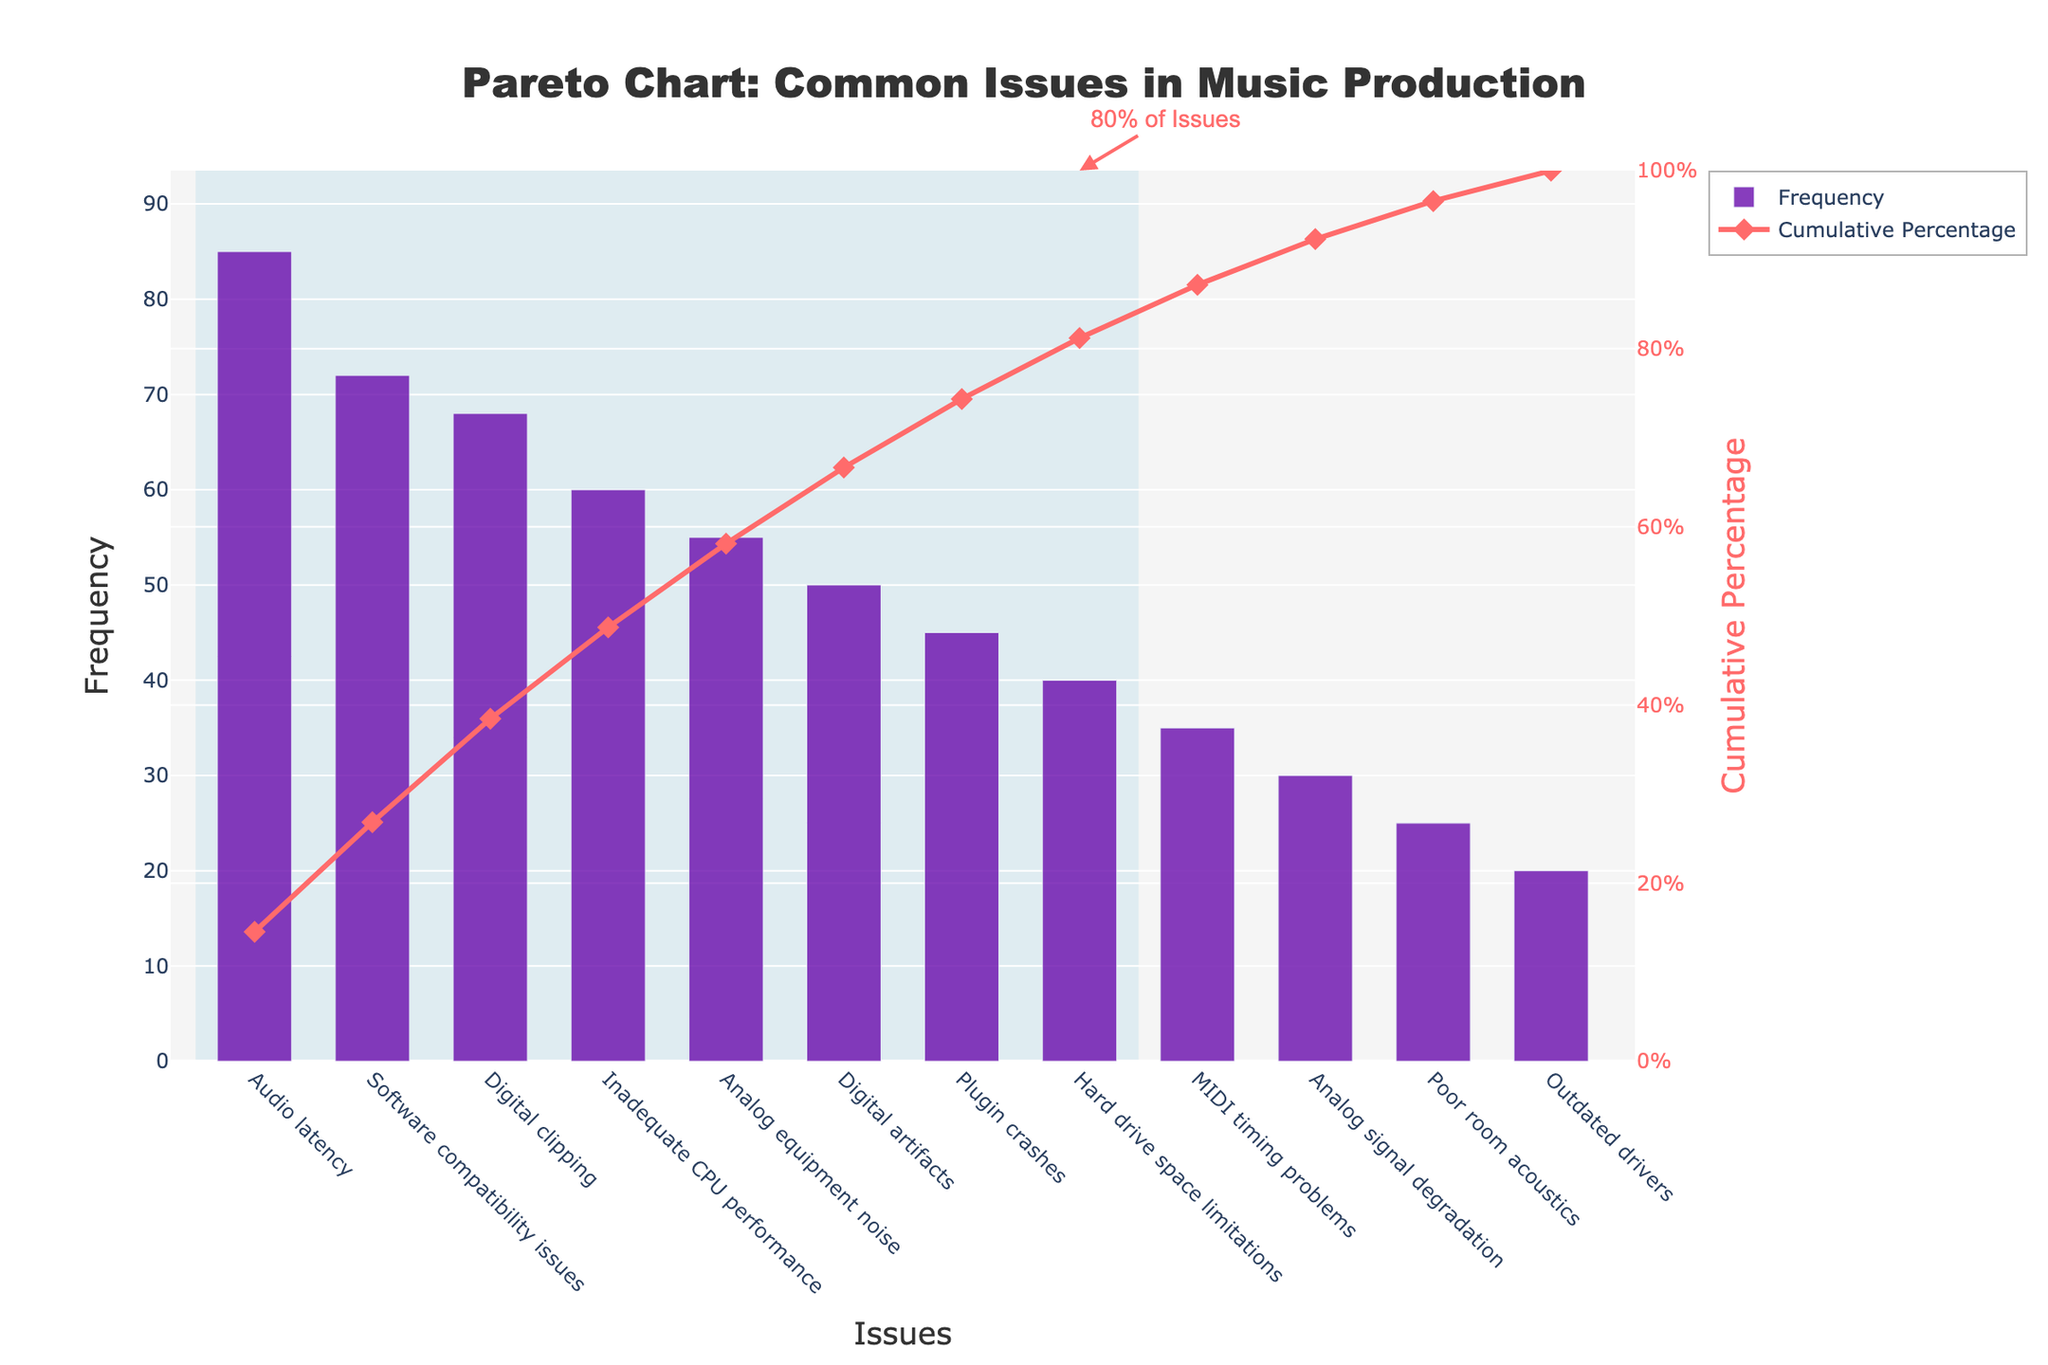What is the title of the chart? The title of the chart can be found at the top center of the figure. It reads "Pareto Chart: Common Issues in Music Production."
Answer: Pareto Chart: Common Issues in Music Production How many issues are identified in the chart? Count the number of unique bars in the chart representing different issues. Each bar corresponds to one issue. There are 12 bars in total.
Answer: 12 Which issue has the highest frequency? Look for the tallest bar on the left side of the chart. This represents "Audio latency."
Answer: Audio latency What is the cumulative percentage for "Software compatibility issues"? Locate the point corresponding to "Software compatibility issues" on the red line representing cumulative percentage. The y-axis on the right shows the percentage. It is approximately around 42%.
Answer: ~42% What percentage of issues account for 80% of the frequency? The chart uses a rectangle to highlight the most significant issues up to 80% of the cumulative percentage. The number of highlighted bars can be counted. There are 7 issues under this highlighted region.
Answer: 7 issues How does the frequency of "Digital clipping" compare to "Analog equipment noise"? Find the bars corresponding to "Digital clipping" and "Analog equipment noise." "Digital clipping" is slightly taller than "Analog equipment noise," which means it has a higher frequency.
Answer: Digital clipping has a higher frequency What is the cumulative percentage after considering "Inadequate CPU performance"? Locate the point representing "Inadequate CPU performance" on the cumulative percentage line. The corresponding percentage on the y-axis (right) is around 72%.
Answer: ~72% Which issue has a higher impact on workflow: "Audio latency" or "Poor room acoustics"? Refer to the data listing both frequency and impact values. Audio latency has an impact of 9.5, while Poor room acoustics has an impact of 8.8. Therefore, Audio latency has a higher impact.
Answer: Audio latency What is the total frequency of the top 3 issues? The top 3 issues are "Audio latency," "Software compatibility issues," and "Digital clipping." Adding their frequencies: 85 (Audio latency) + 72 (Software compatibility issues) + 68 (Digital clipping) = 225
Answer: 225 Explain the significance of the red line in the chart. The red line represents the cumulative percentage of the frequencies of all issues ranked from highest to lowest. This line helps identify the cumulative impact of the most frequent issues. The area under the line shows what portion of the total frequency is contributed by these issues.
Answer: It represents the cumulative frequency percentage 